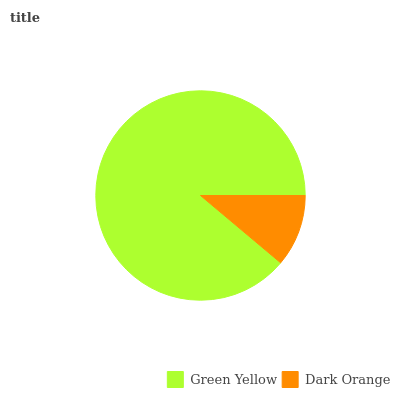Is Dark Orange the minimum?
Answer yes or no. Yes. Is Green Yellow the maximum?
Answer yes or no. Yes. Is Dark Orange the maximum?
Answer yes or no. No. Is Green Yellow greater than Dark Orange?
Answer yes or no. Yes. Is Dark Orange less than Green Yellow?
Answer yes or no. Yes. Is Dark Orange greater than Green Yellow?
Answer yes or no. No. Is Green Yellow less than Dark Orange?
Answer yes or no. No. Is Green Yellow the high median?
Answer yes or no. Yes. Is Dark Orange the low median?
Answer yes or no. Yes. Is Dark Orange the high median?
Answer yes or no. No. Is Green Yellow the low median?
Answer yes or no. No. 